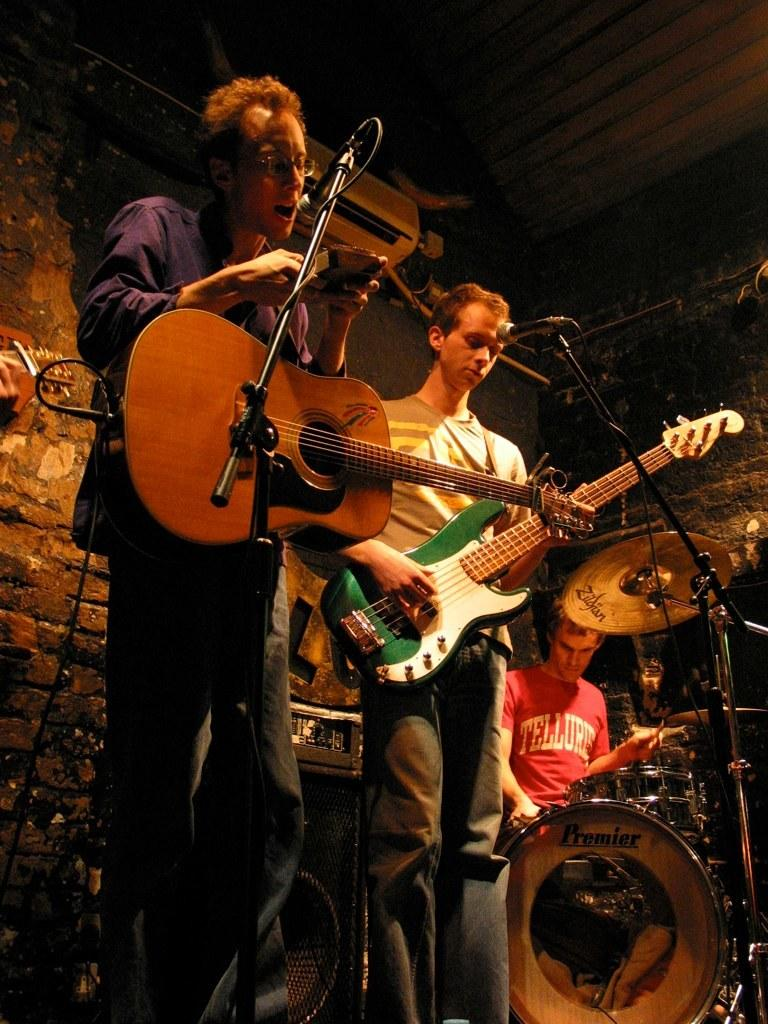What are the people in the image doing? The people in the image are playing musical instruments. What specific instruments can be seen in the image? There are guitars and drums in the image. What equipment is used for amplifying sound in the image? There are microphones (mike's) in the image. What can be seen in the background of the image? There is a wall in the background of the image. What device is visible at the top of the image? There is an air conditioner (AC) on the top of the image. How many eyes can be seen on the guitar in the image? There are no eyes visible on the guitar in the image, as guitars do not have eyes. 